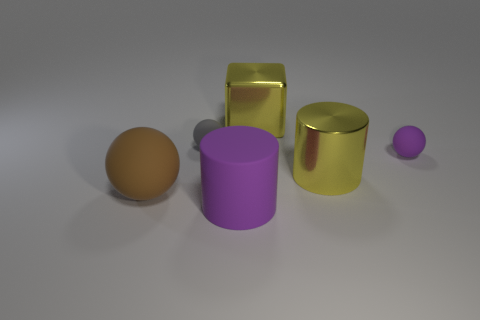Subtract all small purple balls. How many balls are left? 2 Add 3 tiny rubber spheres. How many objects exist? 9 Subtract all yellow cylinders. How many cylinders are left? 1 Subtract 0 gray blocks. How many objects are left? 6 Subtract all cylinders. How many objects are left? 4 Subtract 1 cylinders. How many cylinders are left? 1 Subtract all gray cylinders. Subtract all yellow balls. How many cylinders are left? 2 Subtract all yellow cylinders. How many gray balls are left? 1 Subtract all green blocks. Subtract all shiny things. How many objects are left? 4 Add 5 small gray spheres. How many small gray spheres are left? 6 